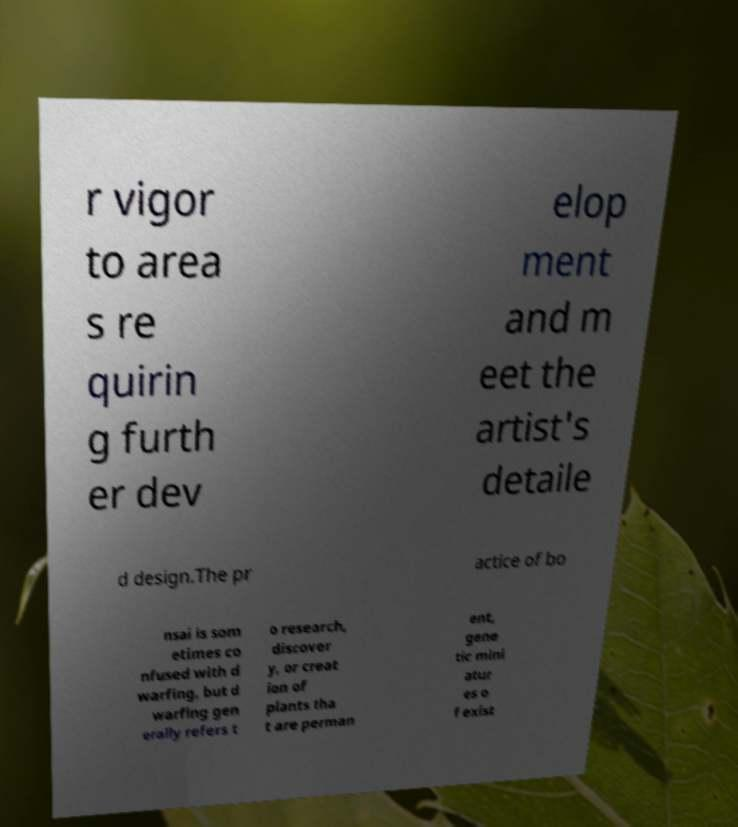Can you accurately transcribe the text from the provided image for me? r vigor to area s re quirin g furth er dev elop ment and m eet the artist's detaile d design.The pr actice of bo nsai is som etimes co nfused with d warfing, but d warfing gen erally refers t o research, discover y, or creat ion of plants tha t are perman ent, gene tic mini atur es o f exist 